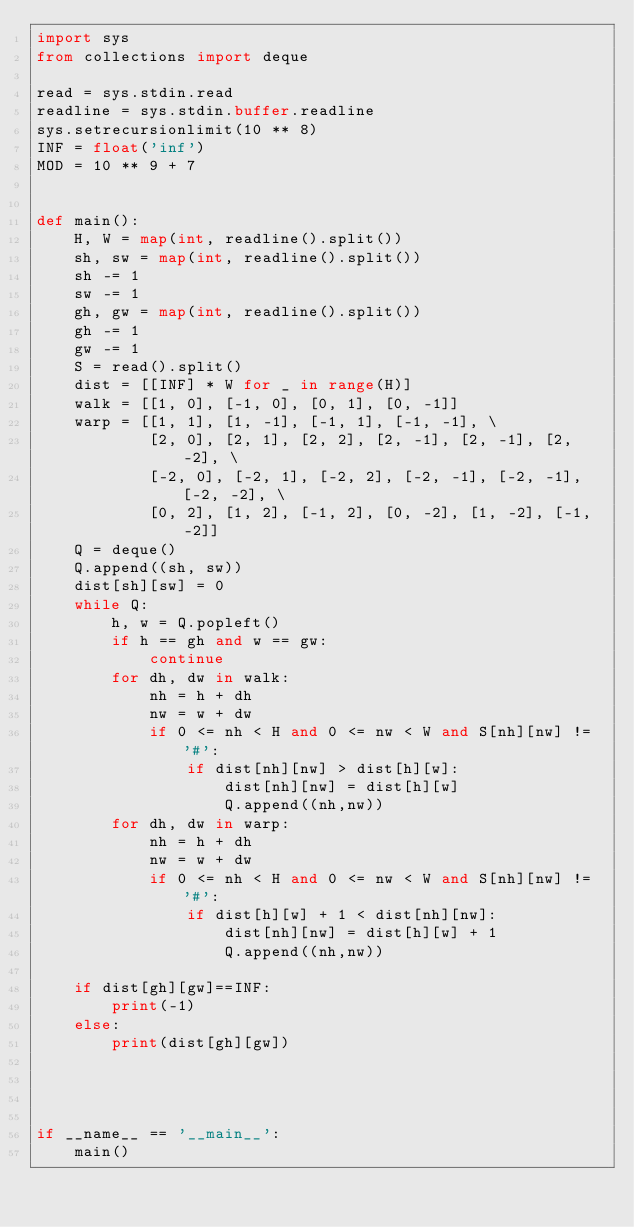<code> <loc_0><loc_0><loc_500><loc_500><_Python_>import sys
from collections import deque

read = sys.stdin.read
readline = sys.stdin.buffer.readline
sys.setrecursionlimit(10 ** 8)
INF = float('inf')
MOD = 10 ** 9 + 7


def main():
    H, W = map(int, readline().split())
    sh, sw = map(int, readline().split())
    sh -= 1
    sw -= 1
    gh, gw = map(int, readline().split())
    gh -= 1
    gw -= 1
    S = read().split()
    dist = [[INF] * W for _ in range(H)]
    walk = [[1, 0], [-1, 0], [0, 1], [0, -1]]
    warp = [[1, 1], [1, -1], [-1, 1], [-1, -1], \
            [2, 0], [2, 1], [2, 2], [2, -1], [2, -1], [2, -2], \
            [-2, 0], [-2, 1], [-2, 2], [-2, -1], [-2, -1], [-2, -2], \
            [0, 2], [1, 2], [-1, 2], [0, -2], [1, -2], [-1, -2]]
    Q = deque()
    Q.append((sh, sw))
    dist[sh][sw] = 0
    while Q:
        h, w = Q.popleft()
        if h == gh and w == gw:
            continue
        for dh, dw in walk:
            nh = h + dh
            nw = w + dw
            if 0 <= nh < H and 0 <= nw < W and S[nh][nw] != '#':
                if dist[nh][nw] > dist[h][w]:
                    dist[nh][nw] = dist[h][w]
                    Q.append((nh,nw))
        for dh, dw in warp:
            nh = h + dh
            nw = w + dw
            if 0 <= nh < H and 0 <= nw < W and S[nh][nw] != '#':
                if dist[h][w] + 1 < dist[nh][nw]:
                    dist[nh][nw] = dist[h][w] + 1
                    Q.append((nh,nw))

    if dist[gh][gw]==INF:
        print(-1)
    else:
        print(dist[gh][gw])




if __name__ == '__main__':
    main()
</code> 